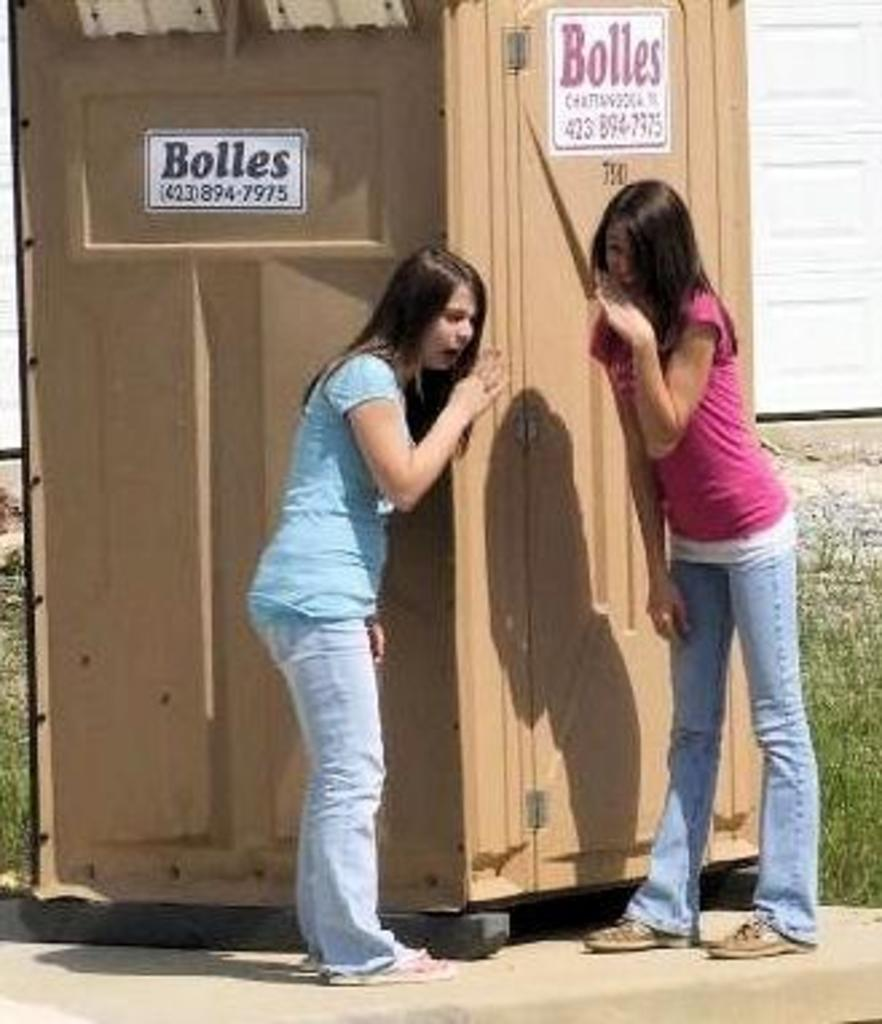How many people are present in the image? There are two girls standing in the image. What can be seen in the background of the image? There is a booth in the image. Are there any natural elements present in the image? Yes, there are plants in the image. What type of grass is growing on the head of one of the girls in the image? There is no grass growing on the head of either girl in the image. 